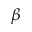Convert formula to latex. <formula><loc_0><loc_0><loc_500><loc_500>\beta</formula> 